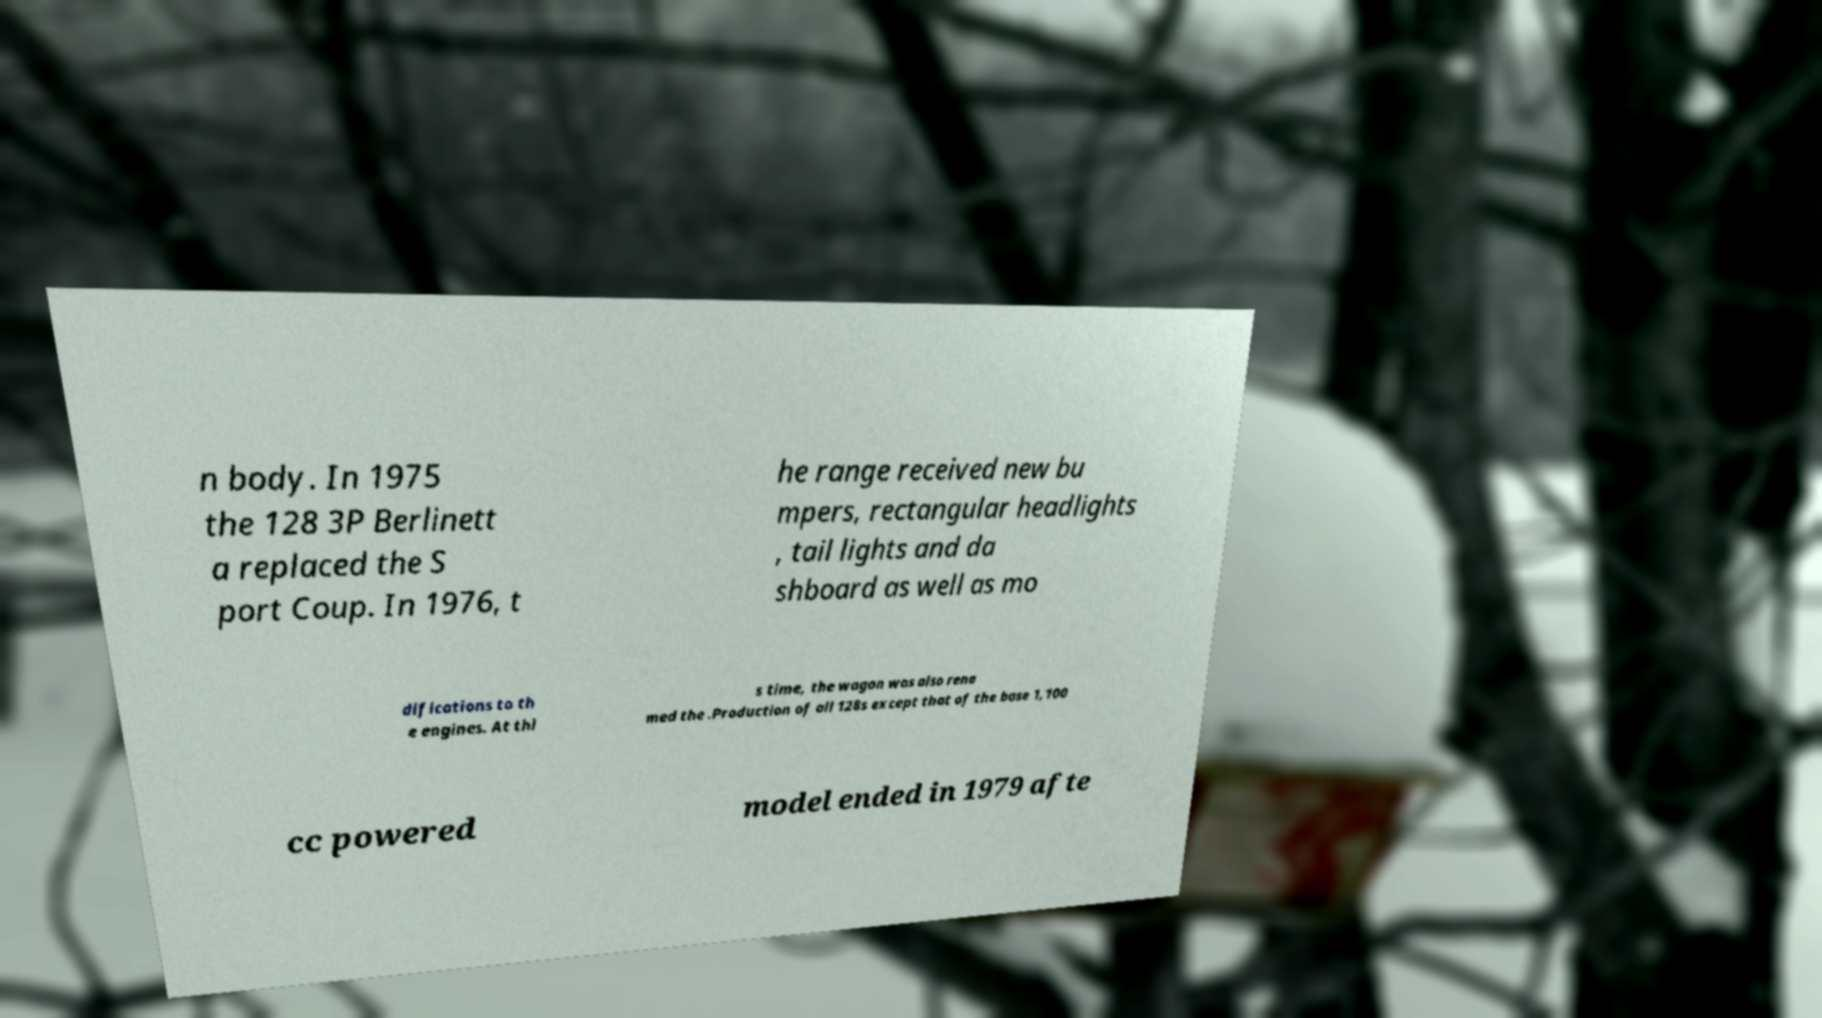I need the written content from this picture converted into text. Can you do that? n body. In 1975 the 128 3P Berlinett a replaced the S port Coup. In 1976, t he range received new bu mpers, rectangular headlights , tail lights and da shboard as well as mo difications to th e engines. At thi s time, the wagon was also rena med the .Production of all 128s except that of the base 1,100 cc powered model ended in 1979 afte 